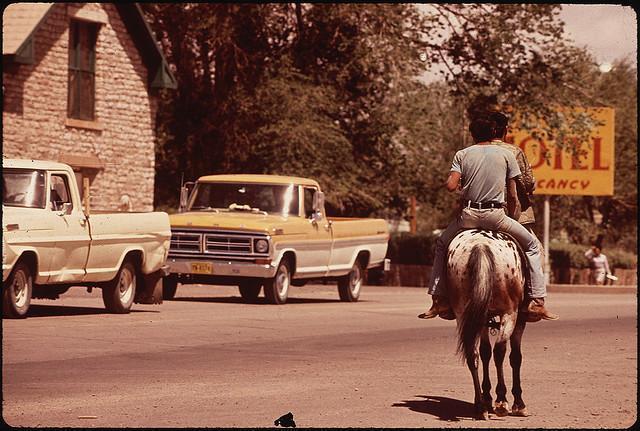How many people are on the horse?
Give a very brief answer. 2. How many trucks are visible?
Give a very brief answer. 2. 